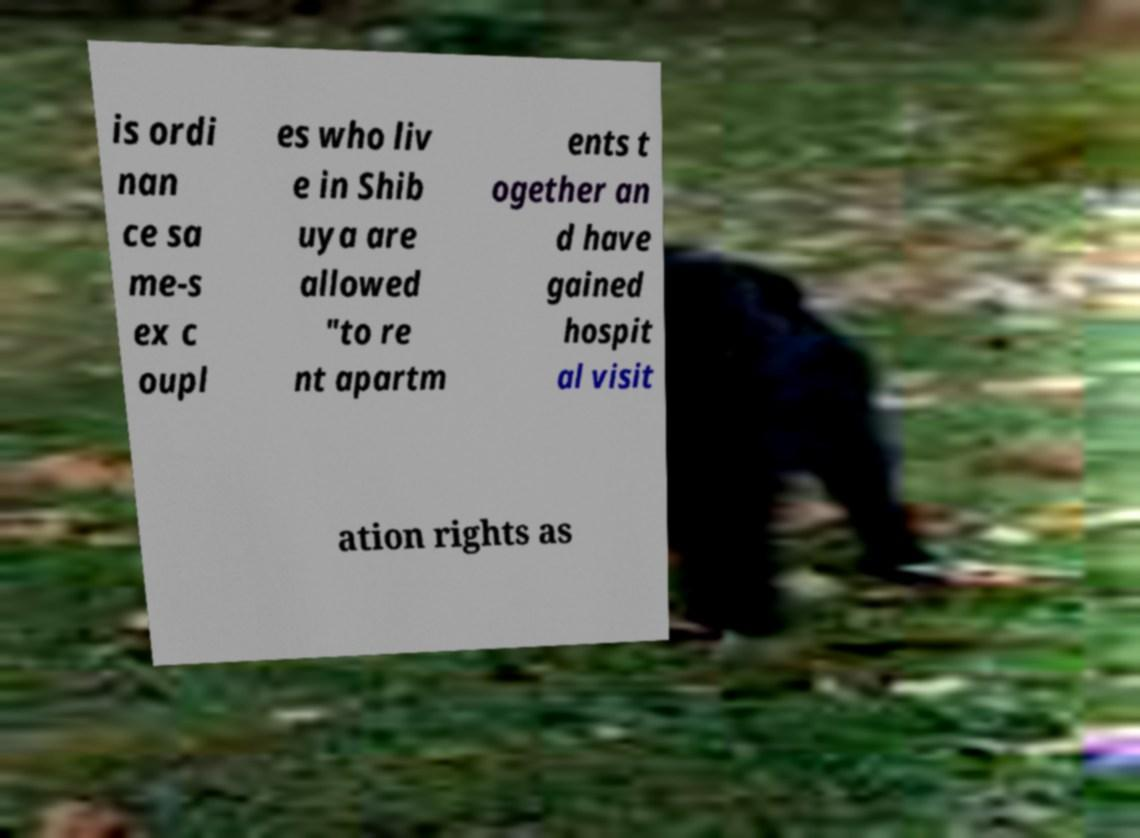Please read and relay the text visible in this image. What does it say? is ordi nan ce sa me-s ex c oupl es who liv e in Shib uya are allowed "to re nt apartm ents t ogether an d have gained hospit al visit ation rights as 